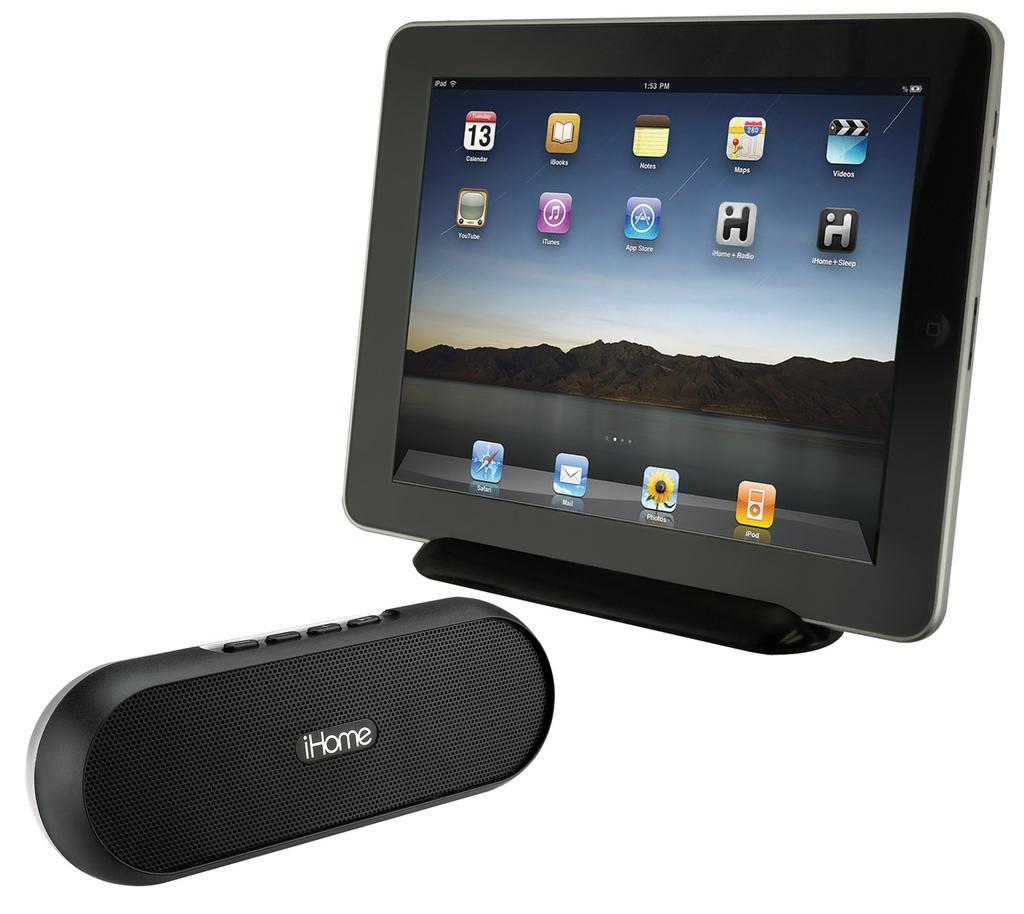How would you summarize this image in a sentence or two? In this picture we observe a black Ihome speaker and a tablet kept in a stand. 